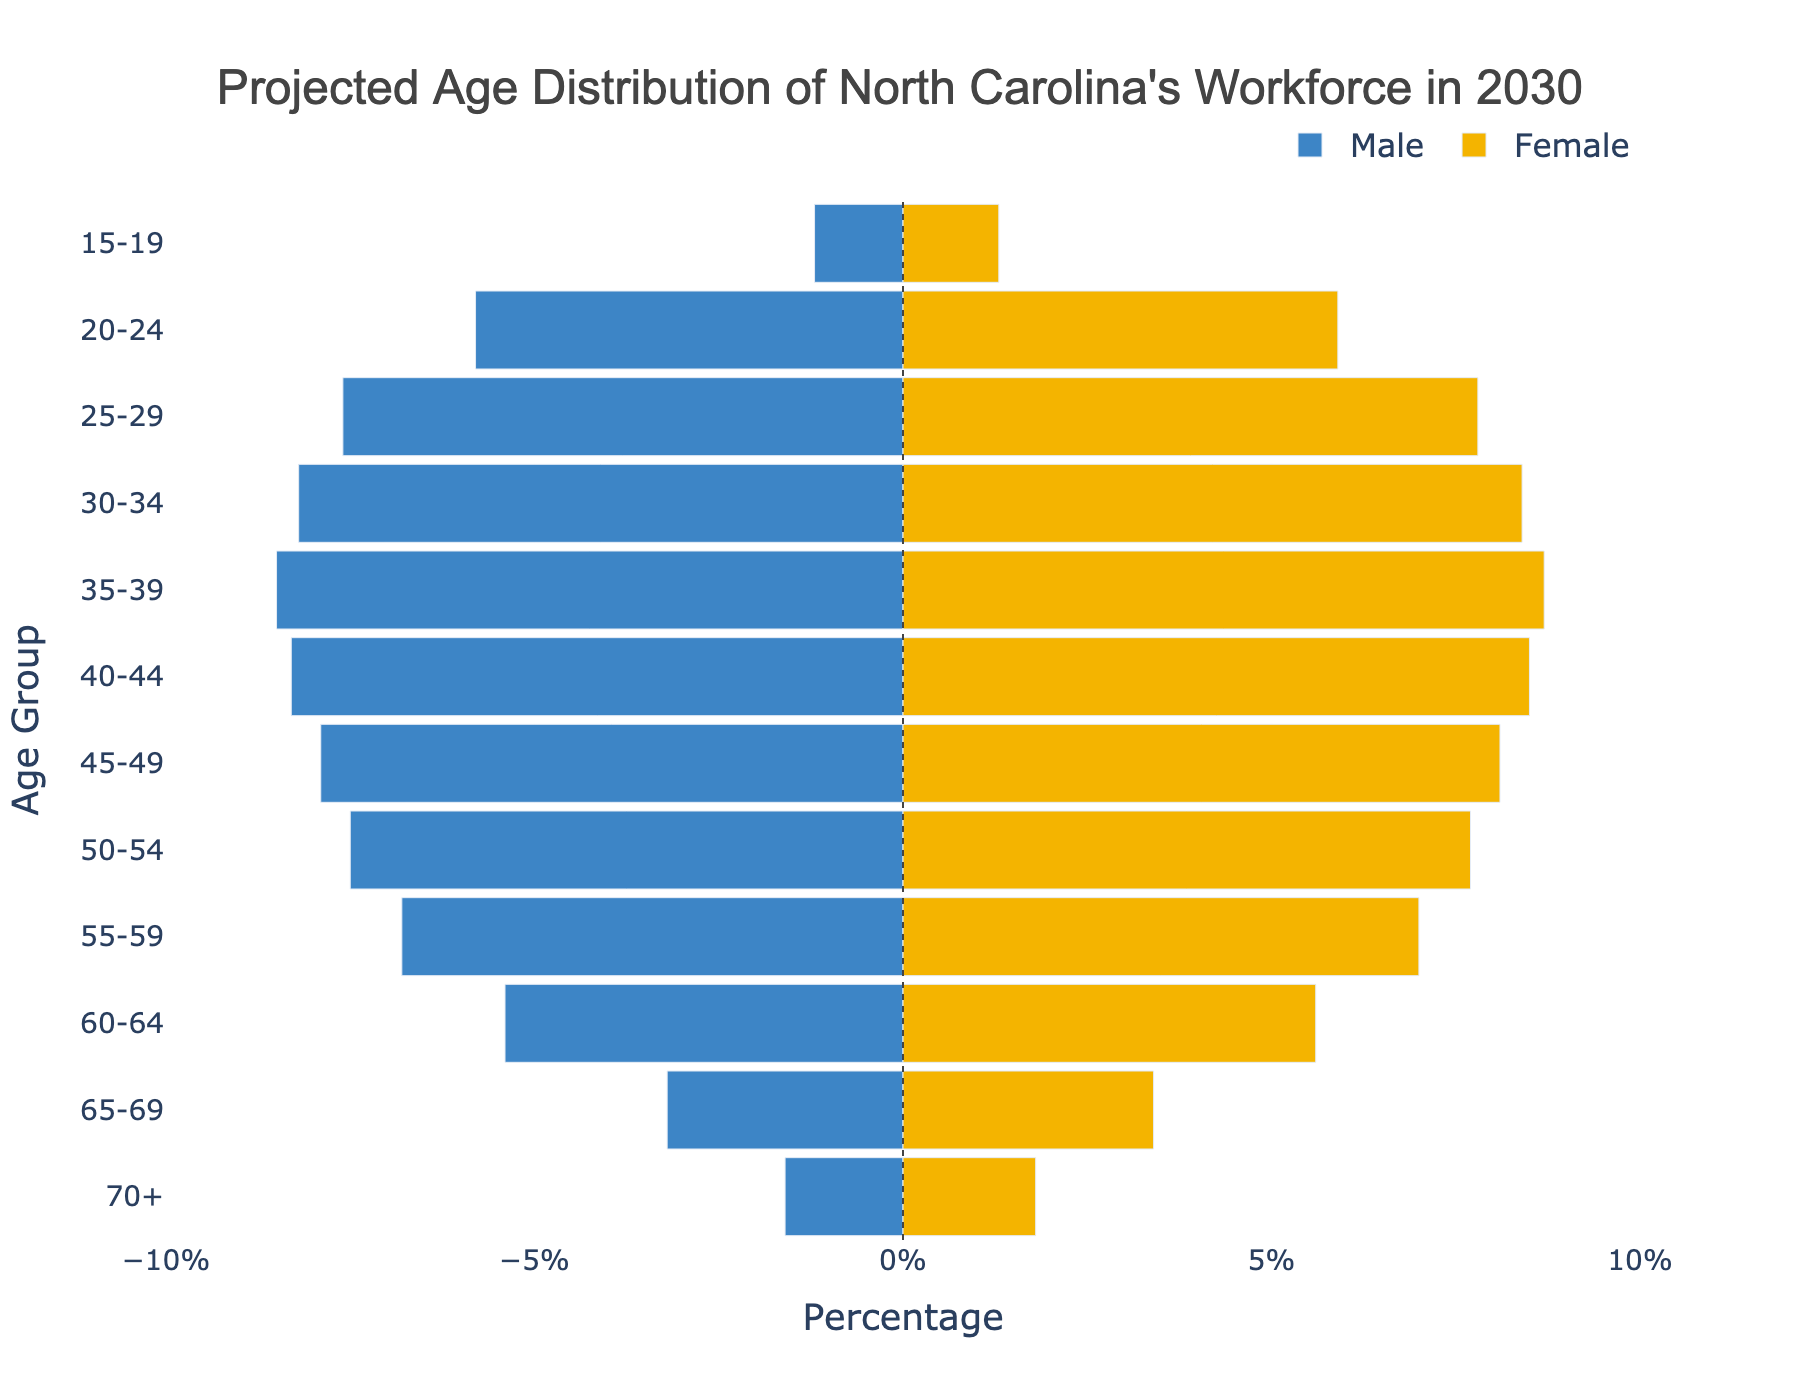What is the title of the figure? The title is located at the top of the figure, presented in a larger and bold font, which reads "Projected Age Distribution of North Carolina's Workforce in 2030".
Answer: Projected Age Distribution of North Carolina's Workforce in 2030 What color represents males in the figure? The color used to represent males is shown in the legend on the right side of the figure, typically blue in this case.
Answer: Blue Which age group has the highest percentage of females? To determine this, scan the Female (yellow) bars and observe the age group with the longest bar. The 35-39 age group has the highest percentage of 8.7%.
Answer: 35-39 What is the total percentage of the workforce aged 45-49 for both genders? Add the percentage values for males and females in the 45-49 age group. Male: 7.9%, Female: 8.1%, Total: 7.9 + 8.1 = 16.0
Answer: 16.0 How does the percentage of males aged 30-34 compare to females in the same age group? Compare the lengths of the bars for the 30-34 age group for both genders. Males are 8.2% and females are 8.4%, indicating females have a slightly higher percentage.
Answer: Females have a slightly higher percentage What is the average percentage of males across all age groups? Sum all the given percentages for males, then divide by the number of age groups. (1.2 + 5.8 + 7.6 + 8.2 + 8.5 + 8.3 + 7.9 + 7.5 + 6.8 + 5.4 + 3.2 + 1.6) / 12 = 5.925
Answer: 5.925 Which gender has a greater representation in the 60-64 age group and by how much? Compare the lengths of the bars for the 60-64 age group, males have 5.4% and females 5.6%. Females have a greater representation by 0.2%.
Answer: Females by 0.2% What percentage of the workforce is aged 20-24 overall? Sum the percentages for both genders in the 20-24 age group. Male: 5.8%, Female: 5.9%, Total: 5.8 + 5.9 = 11.7%
Answer: 11.7% Is there an age group where the percentage of males and females is equal? By reviewing each age group, none have identical percentages for both males and females.
Answer: No What is the percentage difference between males and females in the 70+ age group? Subtract the percentages of males from females in the 70+ age group. Female: 1.8%, Male: 1.6%, Difference: 1.8 - 1.6 = 0.2
Answer: 0.2 